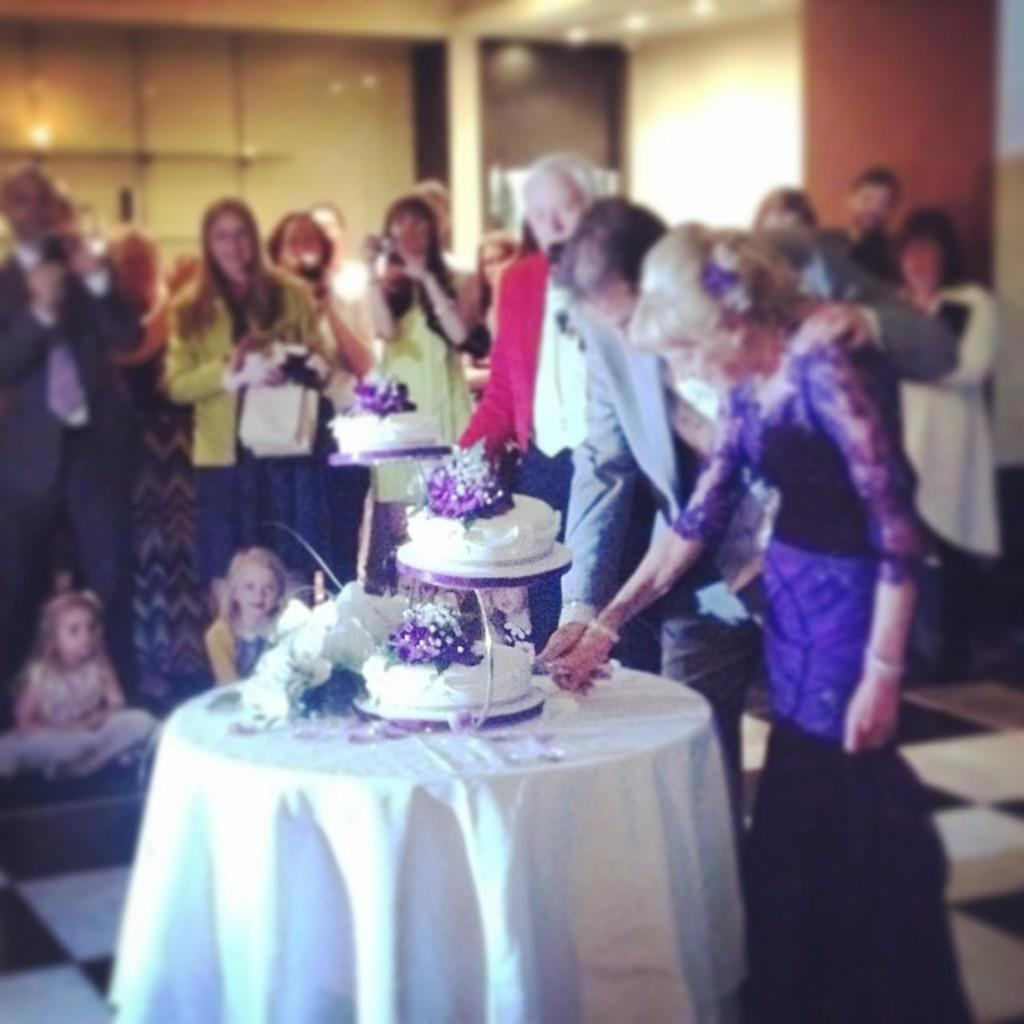Who are the two people in the image? There is a man and a woman in the image. What are the man and woman doing in the image? The man and woman are cutting a cake on a table. Can you describe the setting of the image? There are other men standing in the background of the image, and there is a wall in the background as well. What else can be seen on the table besides the cake? There is a glass visible on the table. What type of paste is being used by the man and woman in the image? There is no paste visible or mentioned in the image; the man and woman are cutting a cake. 